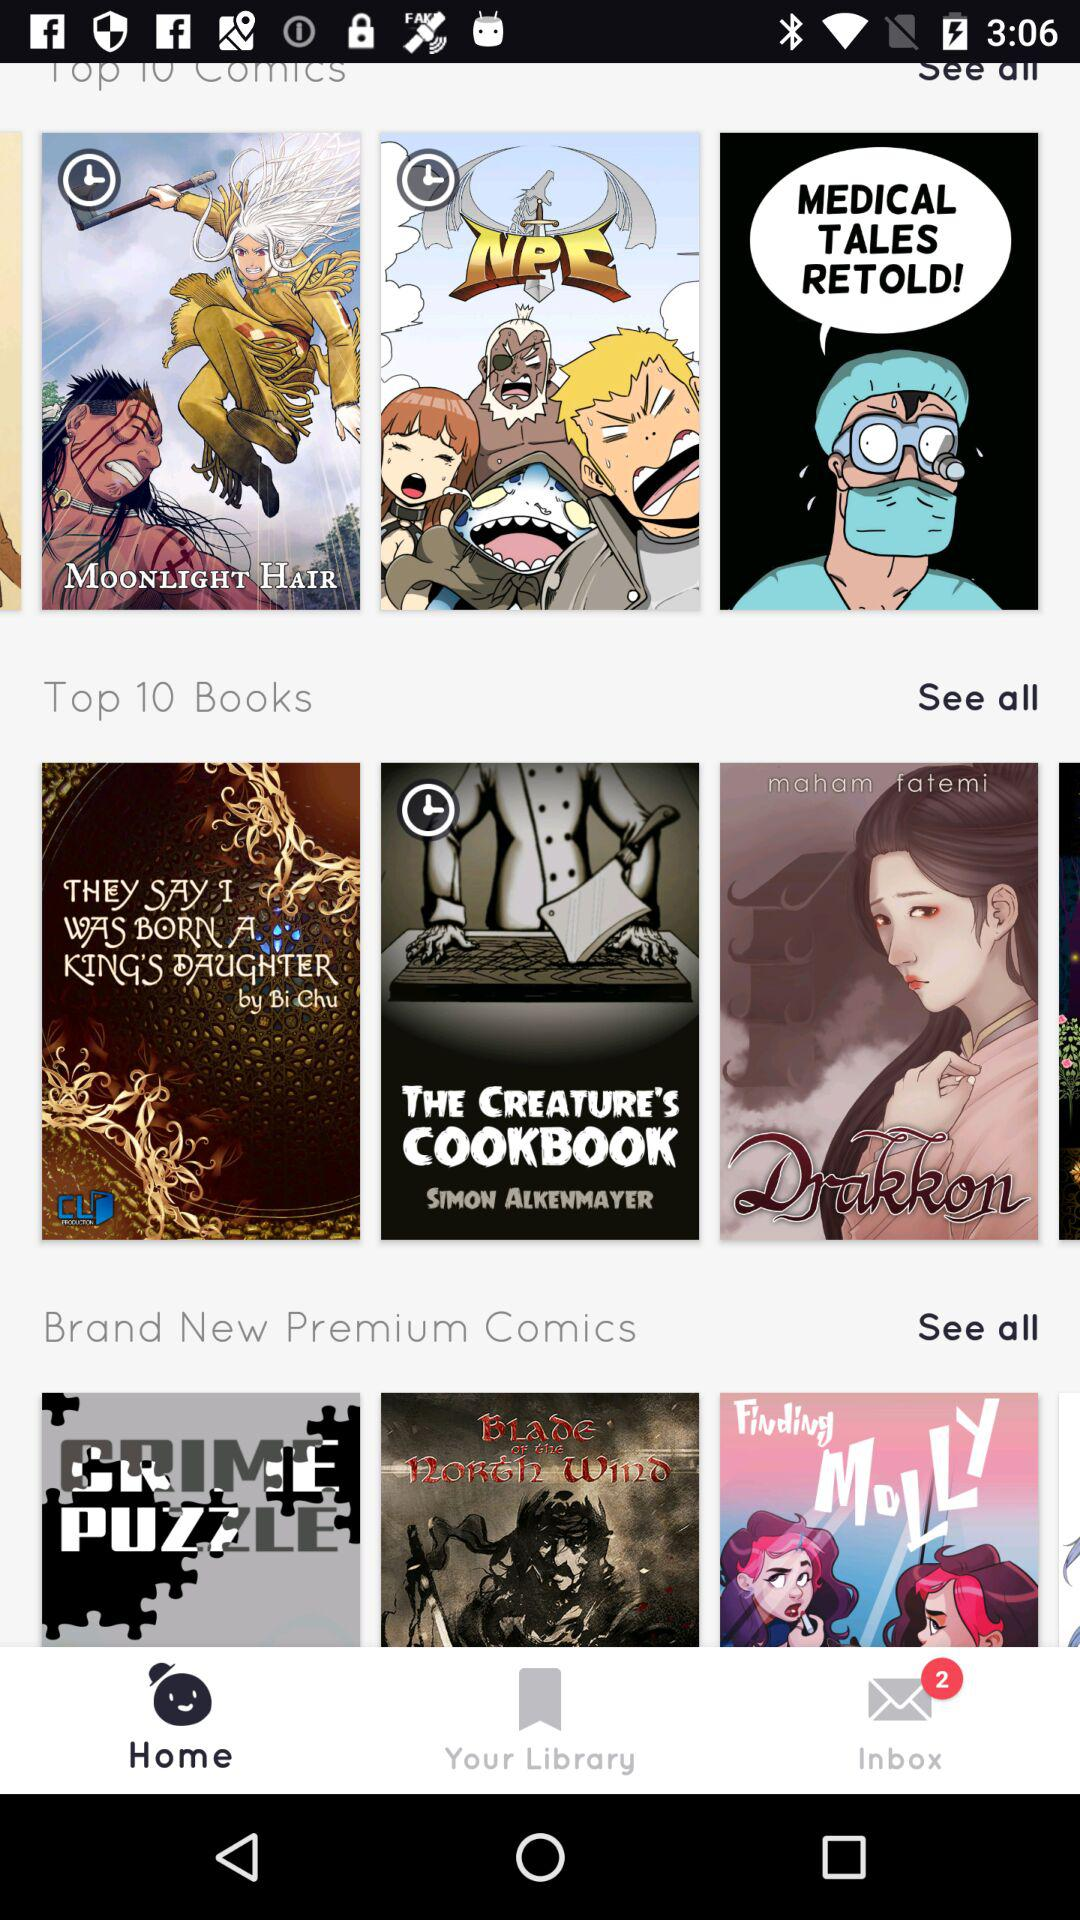Which is the selected tab? The selected tab is "Home". 